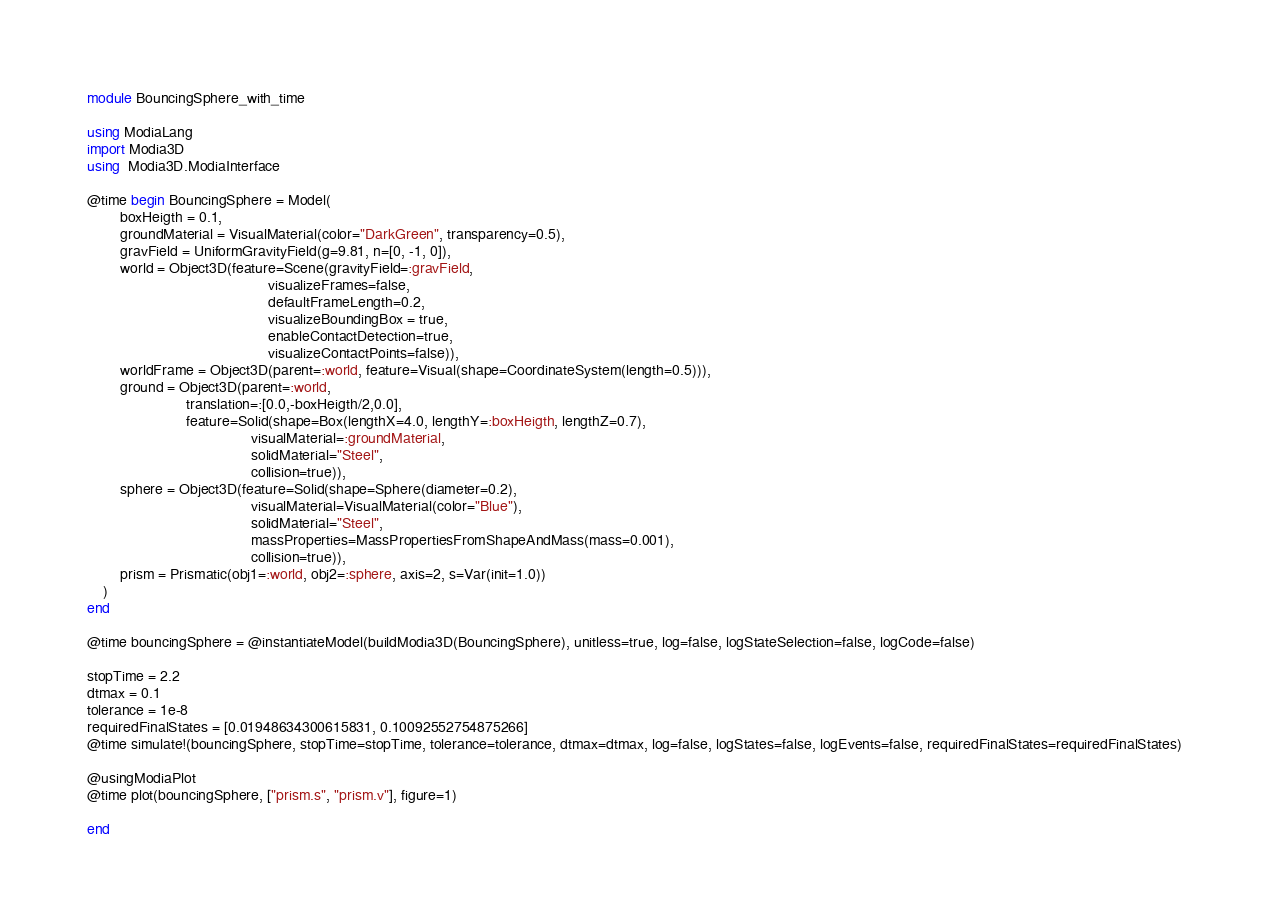<code> <loc_0><loc_0><loc_500><loc_500><_Julia_>module BouncingSphere_with_time

using ModiaLang
import Modia3D
using  Modia3D.ModiaInterface

@time begin BouncingSphere = Model(
        boxHeigth = 0.1,
        groundMaterial = VisualMaterial(color="DarkGreen", transparency=0.5),
        gravField = UniformGravityField(g=9.81, n=[0, -1, 0]),
        world = Object3D(feature=Scene(gravityField=:gravField,
                                            visualizeFrames=false,
                                            defaultFrameLength=0.2,
                                            visualizeBoundingBox = true,
                                            enableContactDetection=true,
                                            visualizeContactPoints=false)),
        worldFrame = Object3D(parent=:world, feature=Visual(shape=CoordinateSystem(length=0.5))),
        ground = Object3D(parent=:world,
                        translation=:[0.0,-boxHeigth/2,0.0],
                        feature=Solid(shape=Box(lengthX=4.0, lengthY=:boxHeigth, lengthZ=0.7),
                                        visualMaterial=:groundMaterial,
                                        solidMaterial="Steel",
                                        collision=true)),
        sphere = Object3D(feature=Solid(shape=Sphere(diameter=0.2),
                                        visualMaterial=VisualMaterial(color="Blue"),
                                        solidMaterial="Steel",
                                        massProperties=MassPropertiesFromShapeAndMass(mass=0.001),
                                        collision=true)),
        prism = Prismatic(obj1=:world, obj2=:sphere, axis=2, s=Var(init=1.0))
    )
end

@time bouncingSphere = @instantiateModel(buildModia3D(BouncingSphere), unitless=true, log=false, logStateSelection=false, logCode=false)

stopTime = 2.2
dtmax = 0.1
tolerance = 1e-8
requiredFinalStates = [0.01948634300615831, 0.10092552754875266]
@time simulate!(bouncingSphere, stopTime=stopTime, tolerance=tolerance, dtmax=dtmax, log=false, logStates=false, logEvents=false, requiredFinalStates=requiredFinalStates)

@usingModiaPlot
@time plot(bouncingSphere, ["prism.s", "prism.v"], figure=1)

end
</code> 